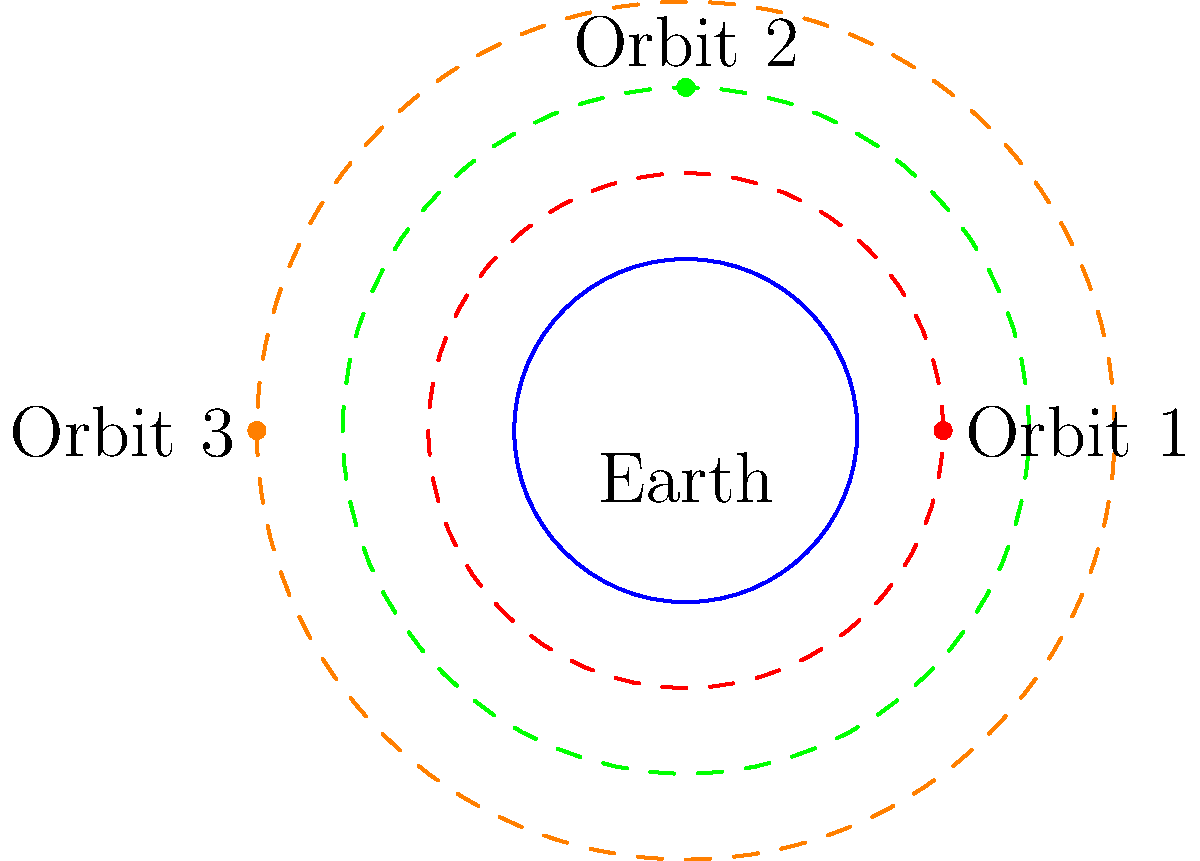As a military intelligence analyst, you're tasked with analyzing a satellite configuration around Earth. The diagram shows three distinct circular orbits with satellites positioned at different points. Given that the group of rotations $SO(2)$ acts on each orbit independently, how many distinct configurations can be achieved by applying elements of $SO(2)$ to each satellite simultaneously? Assume that two configurations are considered distinct if at least one satellite is in a different position. To solve this problem, we need to consider the action of $SO(2)$ (the group of rotations in 2D) on each orbit:

1. Each orbit is a circle, and $SO(2)$ acts transitively on each circle.

2. For each orbit, we can rotate the satellite to any position on that orbit independently of the others.

3. The number of distinct configurations is determined by how we count these independent rotations:

   - Orbit 1: We have infinitely many choices (continuous rotation).
   - Orbit 2: Again, infinitely many choices.
   - Orbit 3: Once more, infinitely many choices.

4. Since we can choose each orbit's rotation independently, we use the multiplication principle.

5. The total number of configurations is the product of the number of choices for each orbit:

   $\infty \times \infty \times \infty = \infty$

6. Therefore, there are infinitely many distinct configurations that can be achieved by applying elements of $SO(2)$ to each satellite simultaneously.

This result highlights the continuous nature of the rotation group $SO(2)$ and its action on circular orbits, which is crucial in satellite positioning and orbital mechanics.
Answer: Infinitely many configurations 